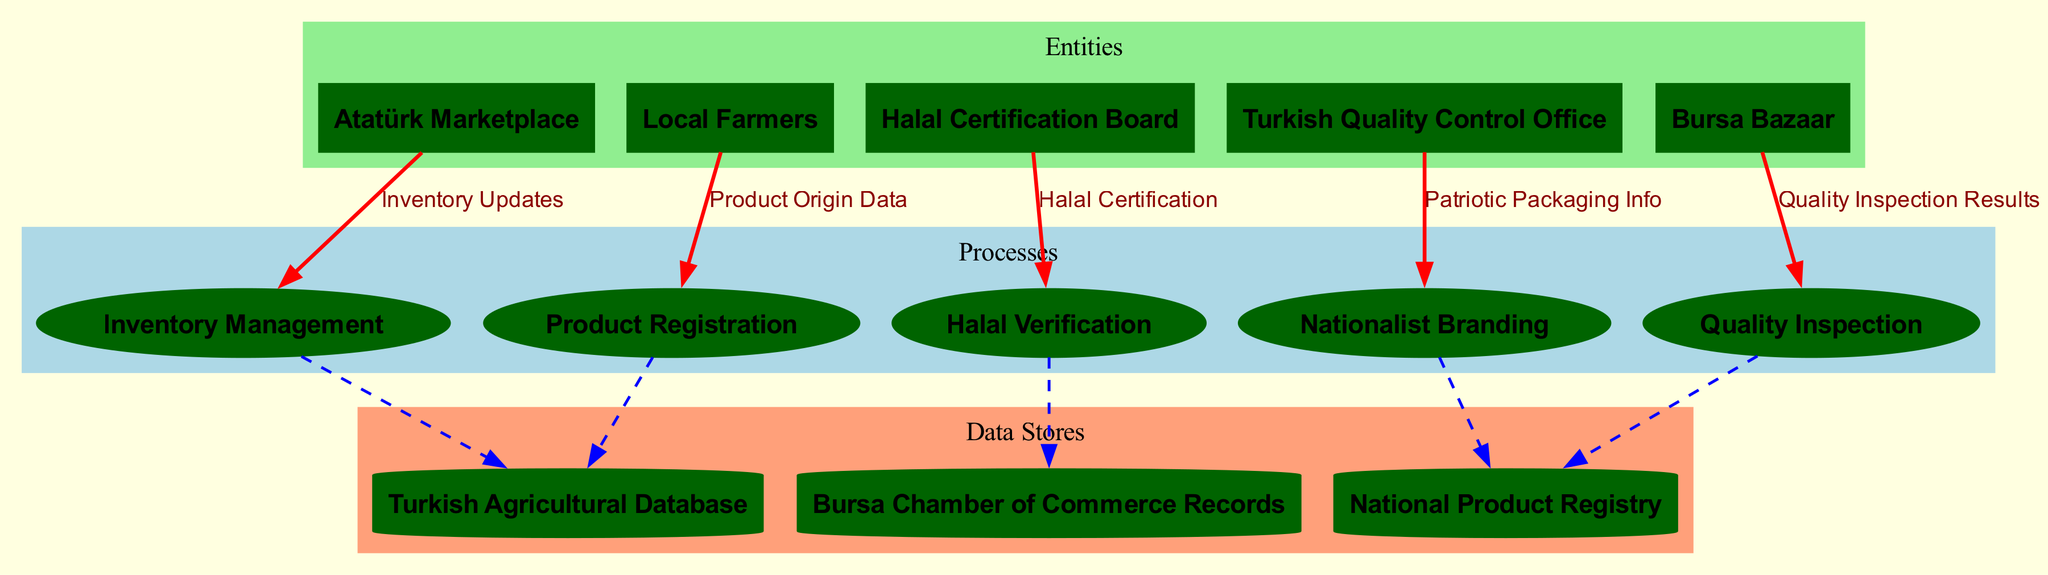What are the entities in the diagram? The diagram includes five entities: Local Farmers, Bursa Bazaar, Halal Certification Board, Atatürk Marketplace, and Turkish Quality Control Office.
Answer: Local Farmers, Bursa Bazaar, Halal Certification Board, Atatürk Marketplace, Turkish Quality Control Office How many processes are represented in the diagram? There are five processes shown in the diagram: Product Registration, Quality Inspection, Halal Verification, Inventory Management, and Nationalist Branding.
Answer: Five Which process is connected to the Halal Certification Board? The Halal Verification process is directly connected to the Halal Certification Board, indicating the role of the board in verifying halal compliance.
Answer: Halal Verification What type of data flows from Local Farmers to the Quality Inspection process? The data flow from Local Farmers to the Quality Inspection process is labeled as Product Origin Data, signifying that this information is essential for quality assessments.
Answer: Product Origin Data Which data store is linked to the Inventory Management process? The Inventory Management process is linked to the National Product Registry, showing that this registry provides necessary data for managing inventory levels.
Answer: National Product Registry If a product has passed the Quality Inspection, what next process does it enter? After passing the Quality Inspection, the product moves into the Halal Verification process, as indicated by the direct connection between these two processes in the diagram.
Answer: Halal Verification How many different types of data flows are indicated in the diagram? The diagram shows five different types of data flows: Product Origin Data, Quality Inspection Results, Halal Certification, Inventory Updates, and Patriotic Packaging Info.
Answer: Five Which entity receives the data flow labeled as Halal Certification? The Halal Certification data flow is directed towards the Atatürk Marketplace, suggesting that this marketplace relies on halal certification for its products.
Answer: Atatürk Marketplace What is the purpose of the Nationalist Branding process? The Nationalist Branding process is likely aimed at promoting and identifying products that embody national pride and values, although the diagram does not specify exact details.
Answer: Promoting National Pride 